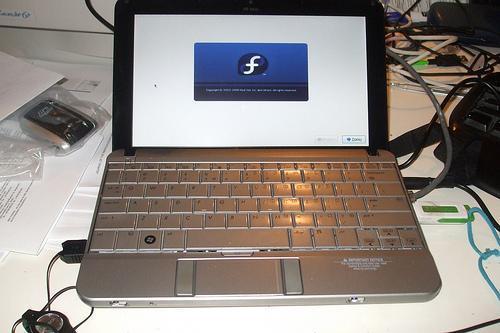How many laptops computers are in the photo?
Give a very brief answer. 1. 